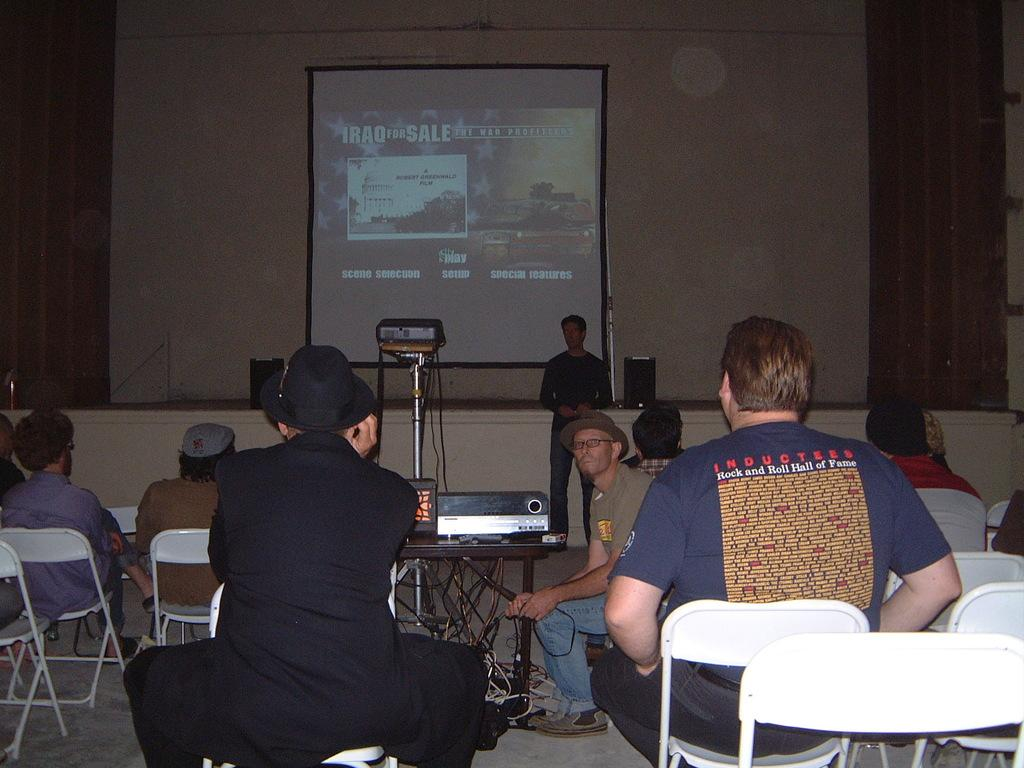What are the people in the image doing? The people in the image are seated on chairs. Is there anyone standing in the image? Yes, there is a man standing in the image. What is the purpose of the projector screen in the image? The projector screen is likely used for displaying visuals during a presentation or event. What device is used to project images onto the screen? There is a projector in the image, which is used to project images onto the screen. Can you see a crown on the head of the man standing in the image? No, there is no crown visible on the head of the man standing in the image. 